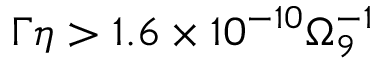Convert formula to latex. <formula><loc_0><loc_0><loc_500><loc_500>\Gamma \eta > 1 . 6 \times 1 0 ^ { - 1 0 } \Omega _ { 9 } ^ { - 1 }</formula> 